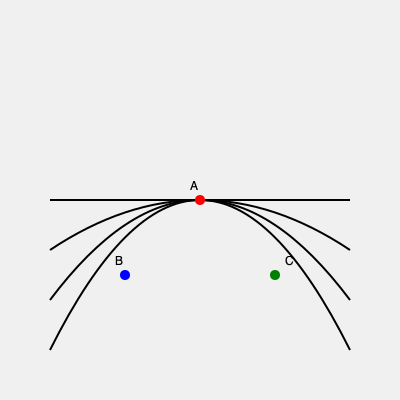Given the topographical map above, which location (A, B, or C) would be most suitable for building a sustainable island residence with minimal environmental impact and optimal views? To determine the most suitable location for a sustainable island residence, we need to consider several factors:

1. Elevation: Higher elevations generally offer better views and improved natural ventilation.
2. Slope: Gentle slopes are preferable for construction, as they require less land modification.
3. Environmental impact: Minimizing earth movement and preserving natural contours is crucial for sustainability.
4. Views: A location that offers panoramic views of the surroundings is desirable.

Analyzing the locations:

A (center, red dot):
- Located at the highest point of the island
- Situated on a relatively flat area (contour lines are far apart)
- Offers 360-degree views of the surroundings
- Requires minimal land modification

B (left, blue dot):
- Located at a lower elevation
- Positioned on a steeper slope (contour lines are closer together)
- Views may be partially obstructed by higher ground
- Would require significant earth movement for construction

C (right, green dot):
- Located at a lower elevation
- Positioned on a steeper slope (contour lines are closer together)
- Views may be partially obstructed by higher ground
- Would require significant earth movement for construction

Considering these factors, location A is the most suitable for building a sustainable island residence. It offers the highest elevation for optimal views, requires minimal land modification due to its relatively flat terrain, and would have the least environmental impact.
Answer: A 